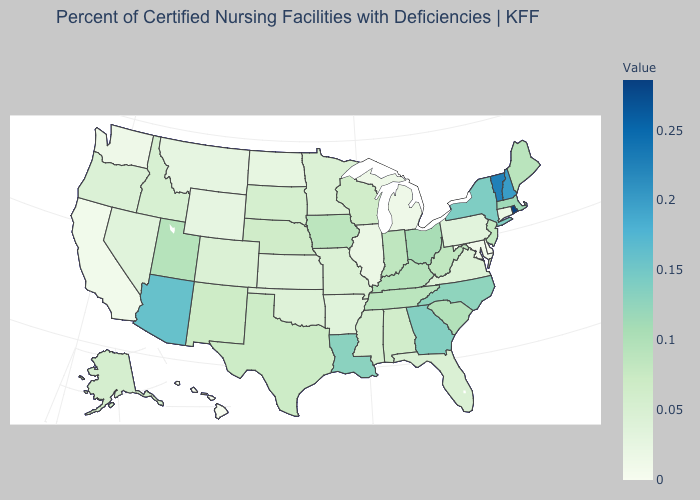Which states have the highest value in the USA?
Write a very short answer. Rhode Island. Does Montana have the lowest value in the West?
Quick response, please. No. Does Mississippi have a higher value than Hawaii?
Short answer required. Yes. Which states hav the highest value in the West?
Short answer required. Arizona. Does the map have missing data?
Concise answer only. No. Which states have the lowest value in the MidWest?
Concise answer only. Michigan. 